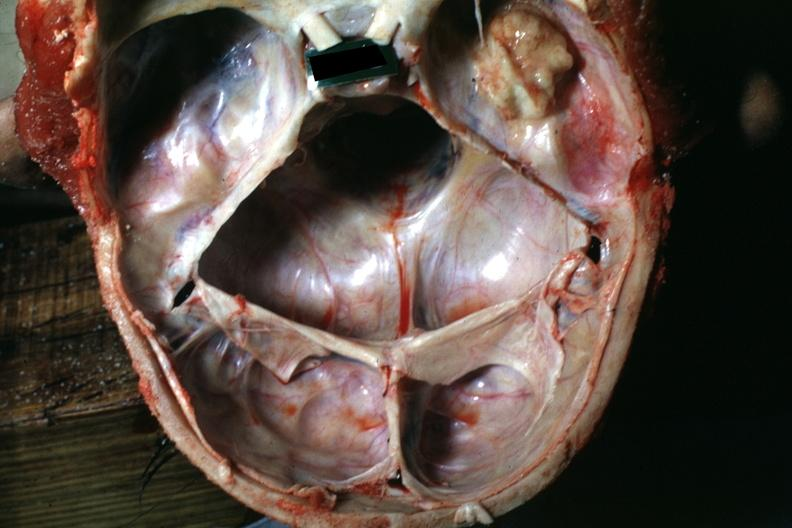does fibroma show large nodular osteoma in right temporal fossa?
Answer the question using a single word or phrase. No 